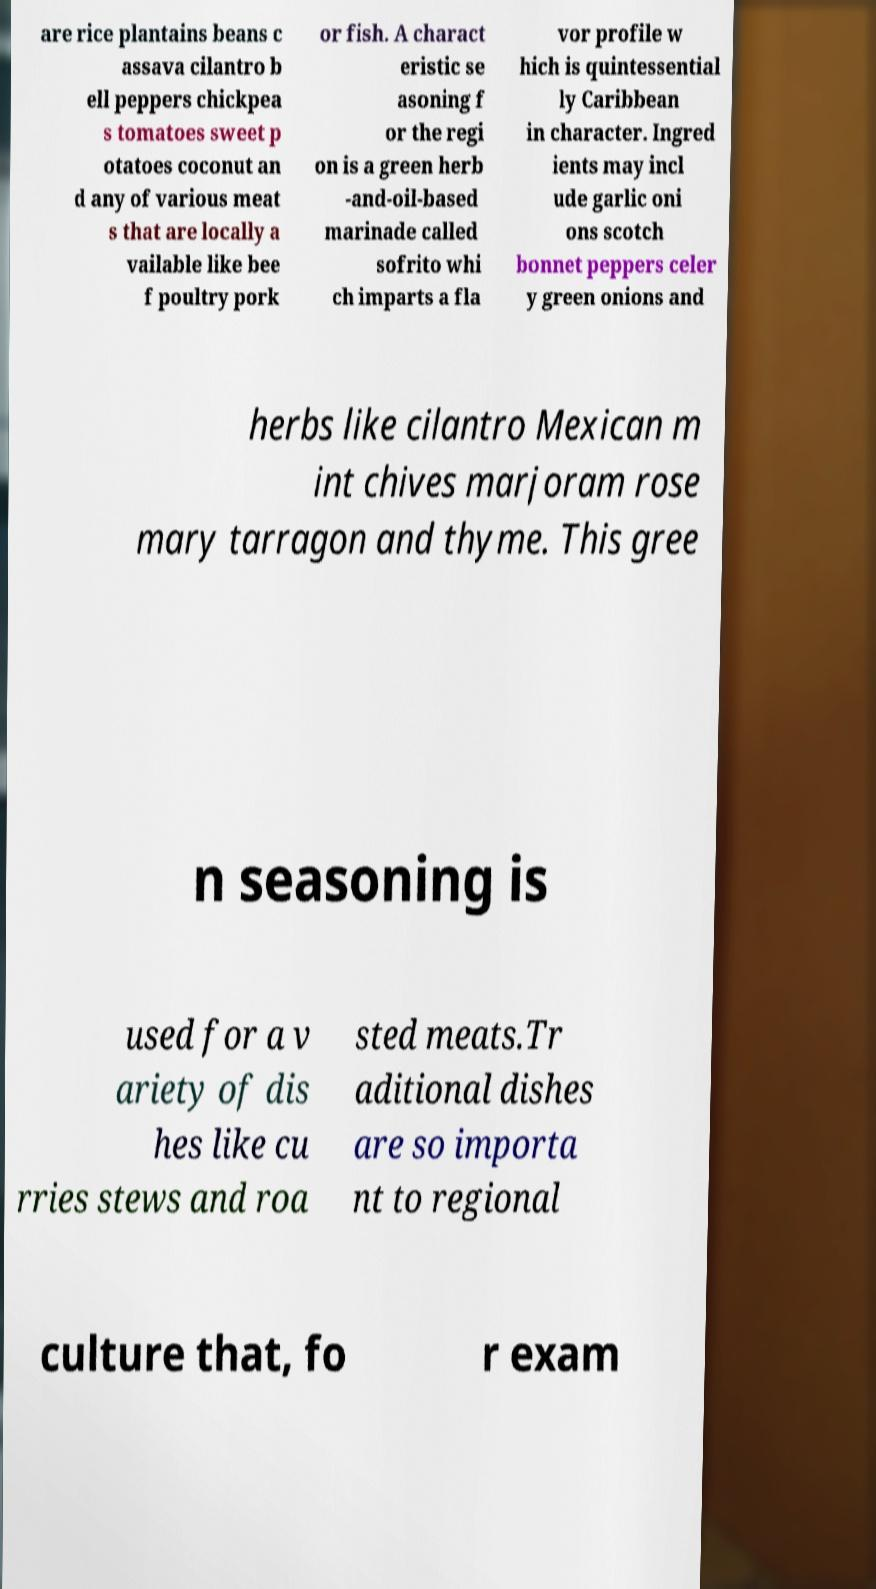I need the written content from this picture converted into text. Can you do that? are rice plantains beans c assava cilantro b ell peppers chickpea s tomatoes sweet p otatoes coconut an d any of various meat s that are locally a vailable like bee f poultry pork or fish. A charact eristic se asoning f or the regi on is a green herb -and-oil-based marinade called sofrito whi ch imparts a fla vor profile w hich is quintessential ly Caribbean in character. Ingred ients may incl ude garlic oni ons scotch bonnet peppers celer y green onions and herbs like cilantro Mexican m int chives marjoram rose mary tarragon and thyme. This gree n seasoning is used for a v ariety of dis hes like cu rries stews and roa sted meats.Tr aditional dishes are so importa nt to regional culture that, fo r exam 